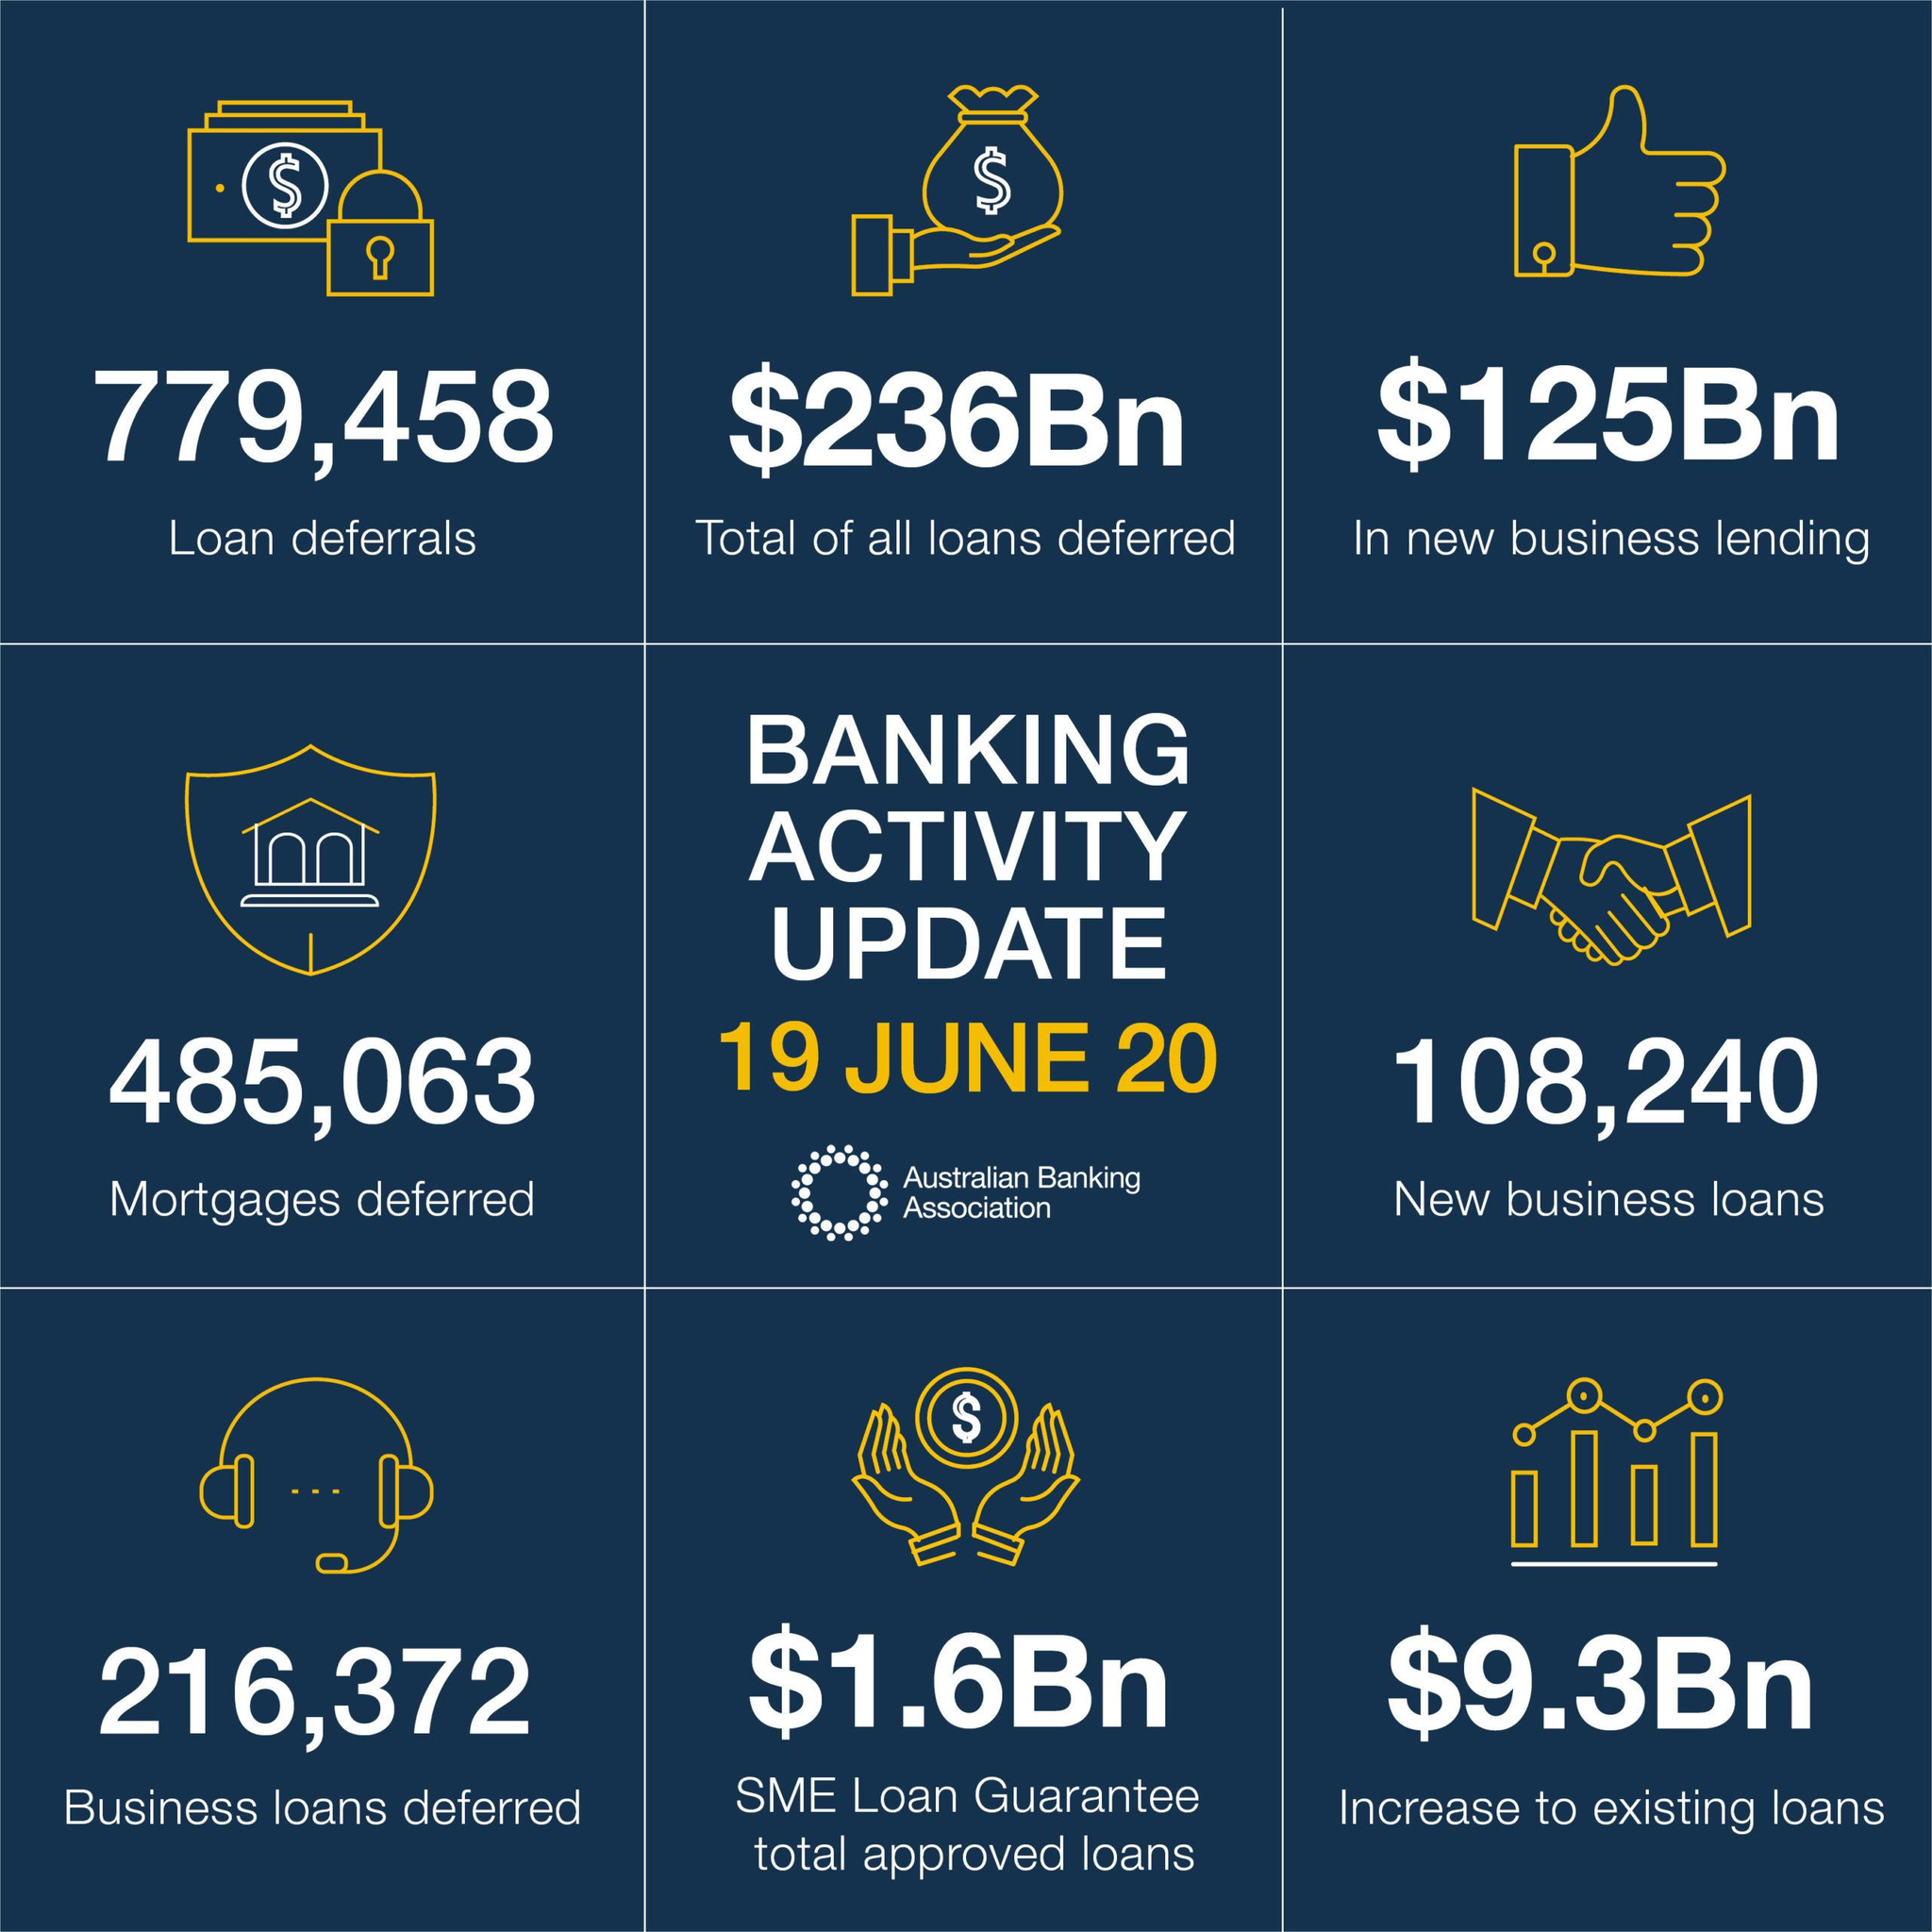Draw attention to some important aspects in this diagram. In 2020, a total of 108,240 new business loans were granted. There are 216,372 deferred business loans. There have been 779,458 loan deferrals. 